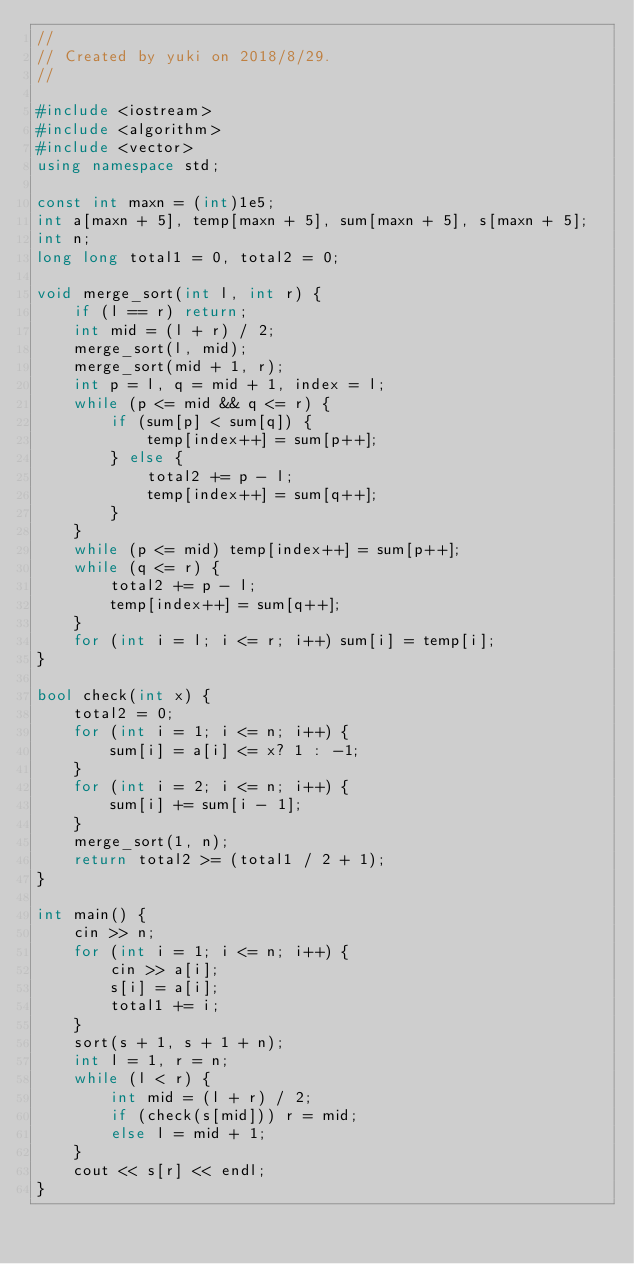<code> <loc_0><loc_0><loc_500><loc_500><_C++_>//
// Created by yuki on 2018/8/29.
//

#include <iostream>
#include <algorithm>
#include <vector>
using namespace std;

const int maxn = (int)1e5;
int a[maxn + 5], temp[maxn + 5], sum[maxn + 5], s[maxn + 5];
int n;
long long total1 = 0, total2 = 0;

void merge_sort(int l, int r) {
    if (l == r) return;
    int mid = (l + r) / 2;
    merge_sort(l, mid);
    merge_sort(mid + 1, r);
    int p = l, q = mid + 1, index = l;
    while (p <= mid && q <= r) {
        if (sum[p] < sum[q]) {
            temp[index++] = sum[p++];
        } else {
            total2 += p - l;
            temp[index++] = sum[q++];
        }
    }
    while (p <= mid) temp[index++] = sum[p++];
    while (q <= r) {
        total2 += p - l;
        temp[index++] = sum[q++];
    }
    for (int i = l; i <= r; i++) sum[i] = temp[i];
}

bool check(int x) {
    total2 = 0;
    for (int i = 1; i <= n; i++) {
        sum[i] = a[i] <= x? 1 : -1;
    }
    for (int i = 2; i <= n; i++) {
        sum[i] += sum[i - 1];
    }
    merge_sort(1, n);
    return total2 >= (total1 / 2 + 1);
}

int main() {
    cin >> n;
    for (int i = 1; i <= n; i++) {
        cin >> a[i];
        s[i] = a[i];
        total1 += i;
    }
    sort(s + 1, s + 1 + n);
    int l = 1, r = n;
    while (l < r) {
        int mid = (l + r) / 2;
        if (check(s[mid])) r = mid;
        else l = mid + 1;
    }
    cout << s[r] << endl;
}
</code> 